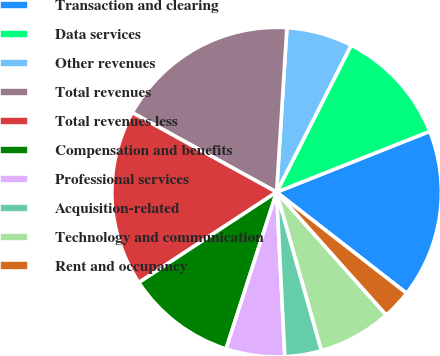<chart> <loc_0><loc_0><loc_500><loc_500><pie_chart><fcel>Transaction and clearing<fcel>Data services<fcel>Other revenues<fcel>Total revenues<fcel>Total revenues less<fcel>Compensation and benefits<fcel>Professional services<fcel>Acquisition-related<fcel>Technology and communication<fcel>Rent and occupancy<nl><fcel>16.54%<fcel>11.51%<fcel>6.48%<fcel>17.98%<fcel>17.26%<fcel>10.79%<fcel>5.76%<fcel>3.6%<fcel>7.2%<fcel>2.88%<nl></chart> 